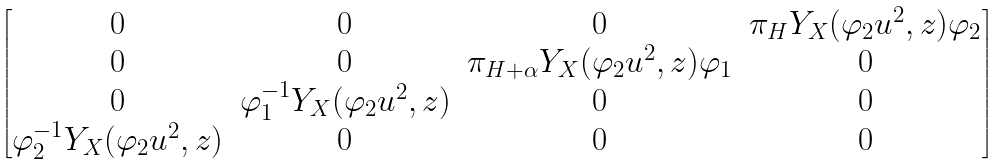Convert formula to latex. <formula><loc_0><loc_0><loc_500><loc_500>\begin{bmatrix} 0 & 0 & 0 & \pi _ { H } Y _ { X } ( \varphi _ { 2 } u ^ { 2 } , z ) \varphi _ { 2 } \\ 0 & 0 & \pi _ { H + \alpha } Y _ { X } ( \varphi _ { 2 } u ^ { 2 } , z ) \varphi _ { 1 } & 0 \\ 0 & \varphi _ { 1 } ^ { - 1 } Y _ { X } ( \varphi _ { 2 } u ^ { 2 } , z ) & 0 & 0 \\ \varphi _ { 2 } ^ { - 1 } Y _ { X } ( \varphi _ { 2 } u ^ { 2 } , z ) & 0 & 0 & 0 \end{bmatrix}</formula> 